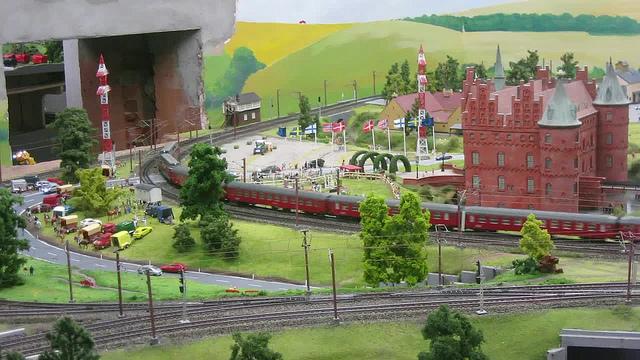Does this look like a real place or a model?
Concise answer only. Model. What number of trees are on this scene?
Give a very brief answer. 19. What are those green things?
Quick response, please. Trees. Is it likely this was made in a day?
Keep it brief. No. 